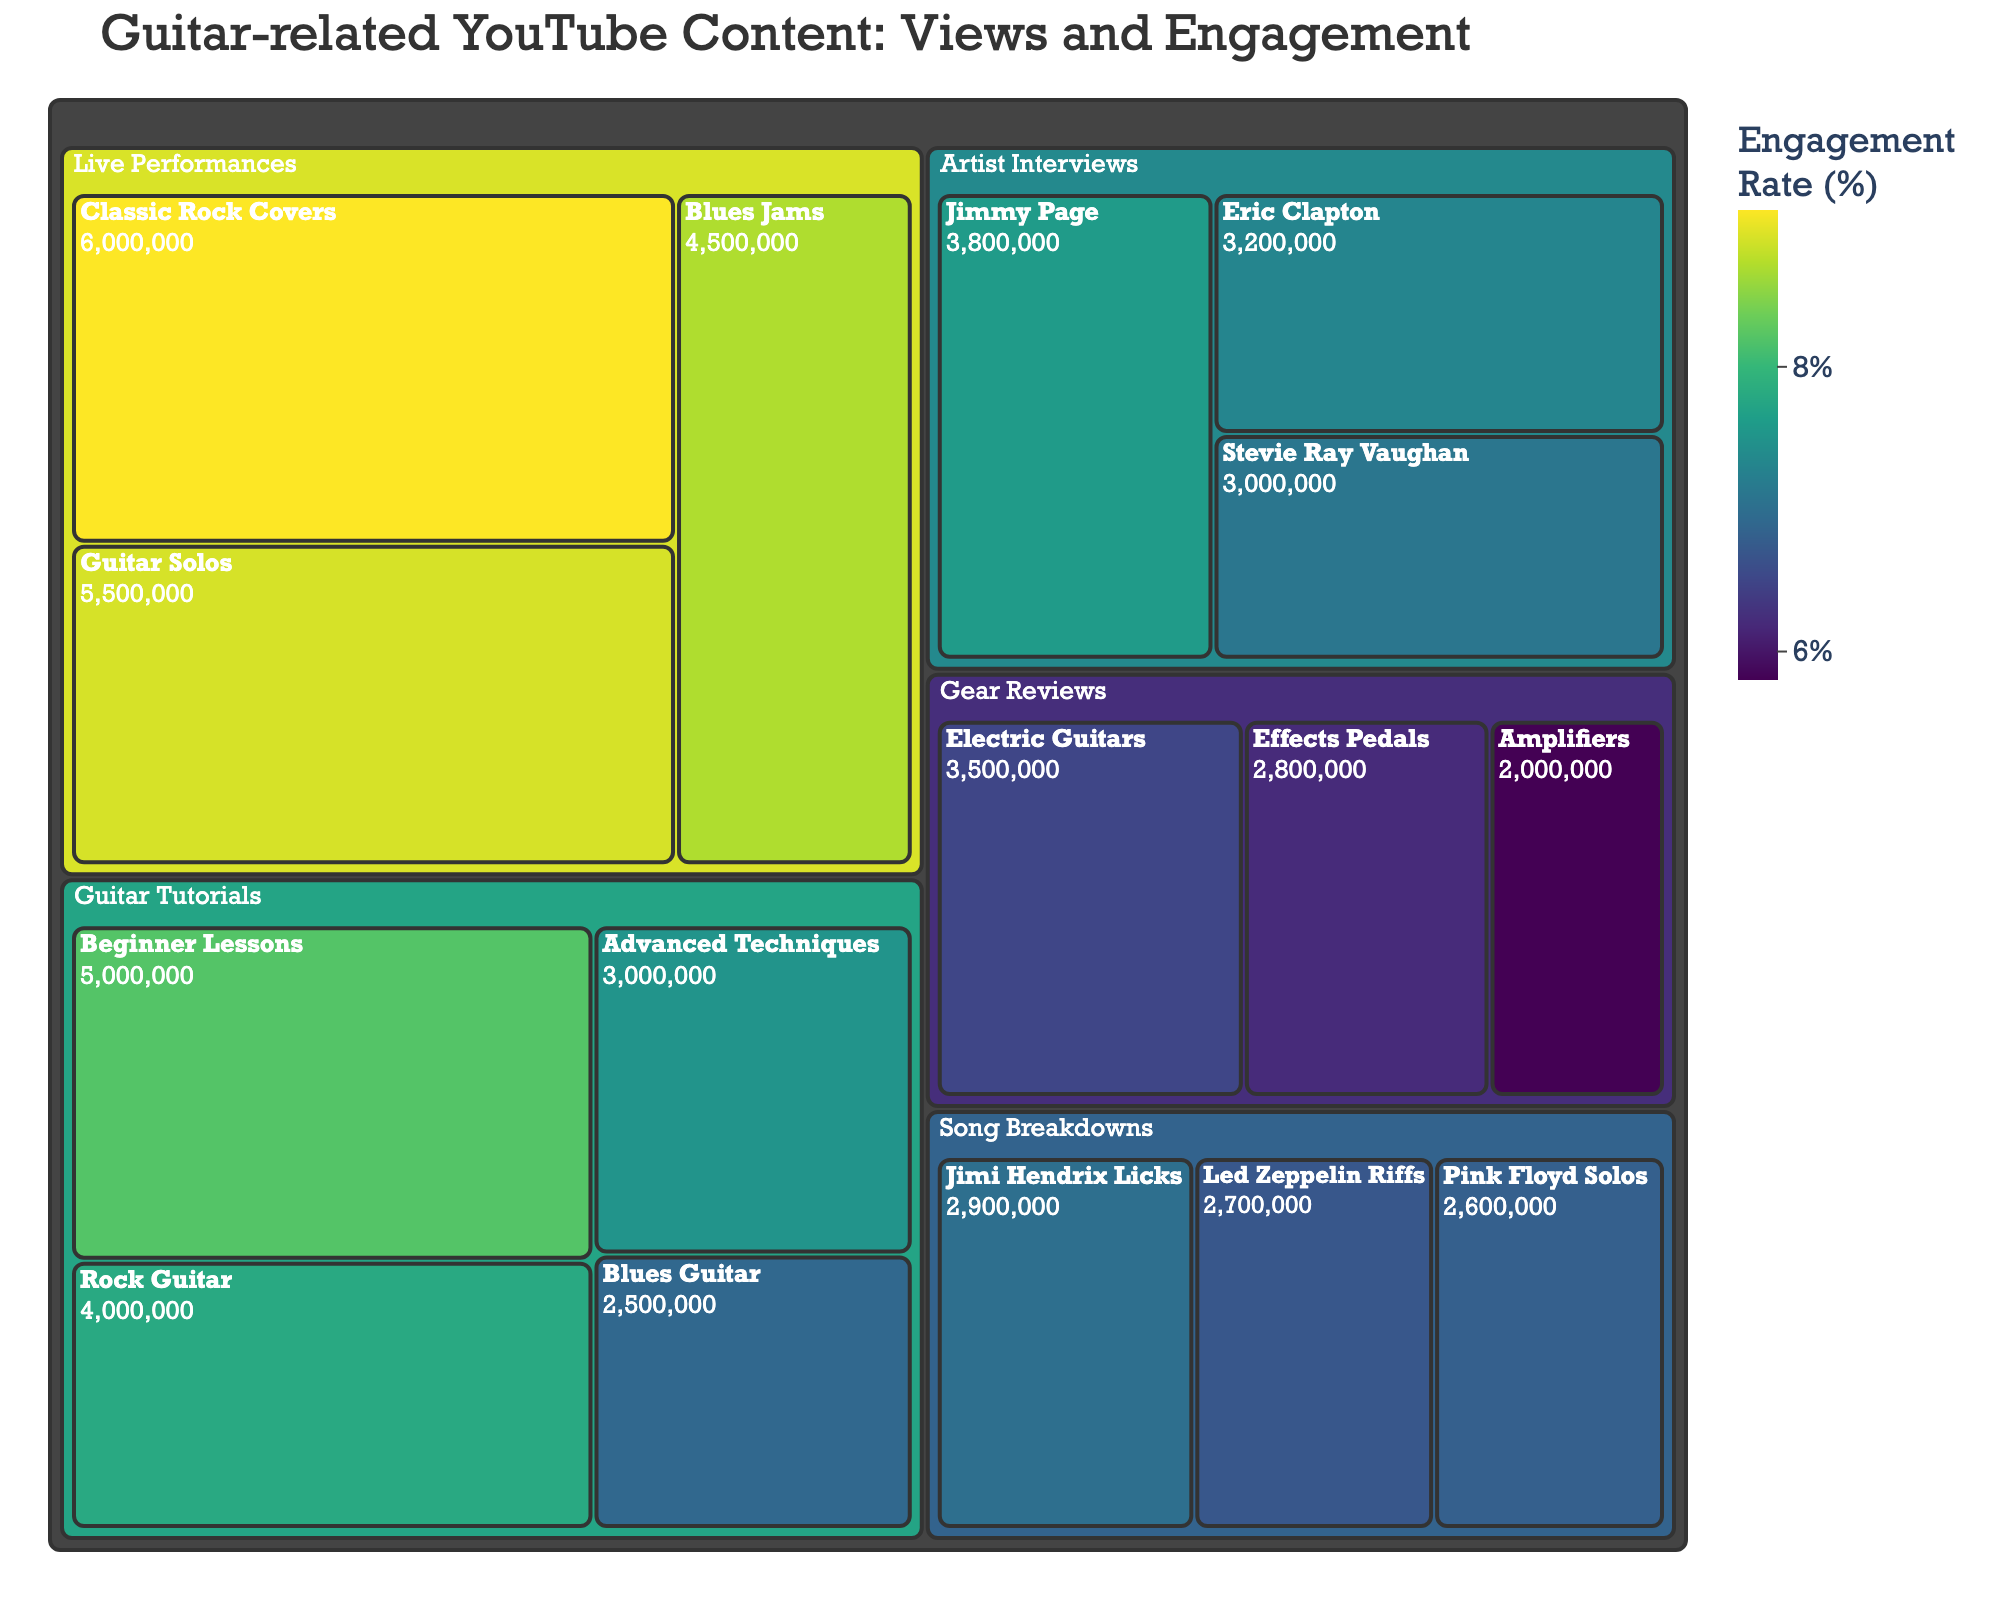What's the category with the highest total views? To find the category with the highest total views, look at the largest tiles. "Live Performances" has "Classic Rock Covers", "Blues Jams", and "Guitar Solos" with views summing up to 16,000,000, which is more than any other category.
Answer: Live Performances Which subcategory has the highest engagement rate? Examine the color intensity of the subcategories. The darkest tile represents the highest engagement. "Classic Rock Covers" in "Live Performances" is 9.1%.
Answer: Classic Rock Covers How many categories are displayed in the Treemap? The Treemap shows categories and subcategories. Count the main boxes. These include "Guitar Tutorials", "Gear Reviews", "Live Performances", "Artist Interviews", and "Song Breakdowns".
Answer: 5 What's the average engagement rate for Guitar Tutorials? Average the engagement rates of the subcategories within "Guitar Tutorials": (8.2 + 7.5 + 6.9 + 7.8) / 4.
Answer: 7.6 Which has more total views: "Artist Interviews" or "Song Breakdowns"? Sum the views for each: Artist Interviews (3200000 + 3800000 + 3000000) = 10,000,000; Song Breakdowns (2700000 + 2900000 + 2600000) = 8,200,000.
Answer: Artist Interviews What is the most popular subcategory within "Gear Reviews"? Check the subcategories: "Electric Guitars" has 3,500,000 views, which is the highest in "Gear Reviews".
Answer: Electric Guitars Which category has the lowest overall engagement rate? Identify the category with the lightest color, indicating low engagement rates. "Gear Reviews" has subcategories with engagement rates around 5.8-6.5%.
Answer: Gear Reviews What's the engagement rate range in the Treemap? Find the lowest and highest engagement rates among all subcategories. The range is from 5.8% to 9.1%.
Answer: 5.8% to 9.1% How does the engagement rate of "Guitar Solos" compare to "Blues Jams"? Look at the engagement rates: "Guitar Solos" is 8.9% and "Blues Jams" is 8.7%.
Answer: Guitar Solos has a higher engagement rate Name a subcategory in "Song Breakdowns" with an engagement rate higher than 7%. Verify each subcategory: "Jimi Hendrix Licks" has an engagement rate of 7.0%.
Answer: Jimi Hendrix Licks 